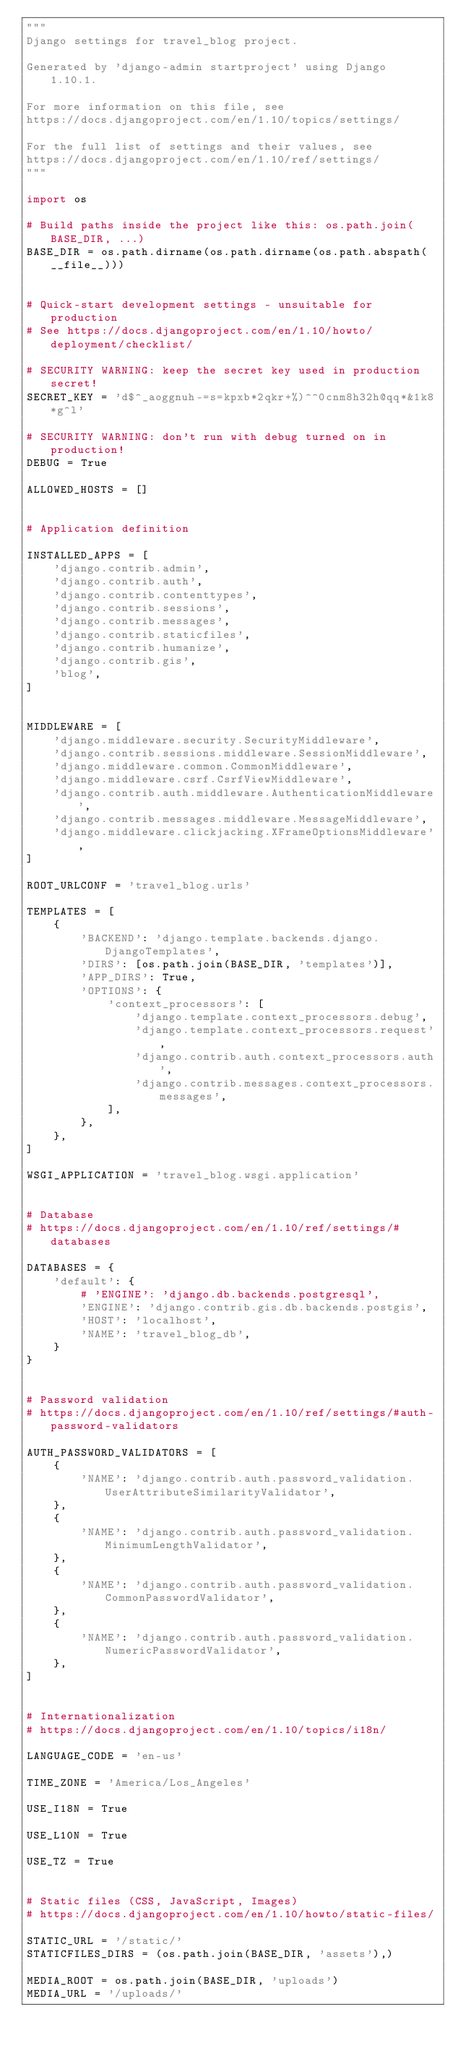Convert code to text. <code><loc_0><loc_0><loc_500><loc_500><_Python_>"""
Django settings for travel_blog project.

Generated by 'django-admin startproject' using Django 1.10.1.

For more information on this file, see
https://docs.djangoproject.com/en/1.10/topics/settings/

For the full list of settings and their values, see
https://docs.djangoproject.com/en/1.10/ref/settings/
"""

import os

# Build paths inside the project like this: os.path.join(BASE_DIR, ...)
BASE_DIR = os.path.dirname(os.path.dirname(os.path.abspath(__file__)))


# Quick-start development settings - unsuitable for production
# See https://docs.djangoproject.com/en/1.10/howto/deployment/checklist/

# SECURITY WARNING: keep the secret key used in production secret!
SECRET_KEY = 'd$^_aoggnuh-=s=kpxb*2qkr+%)^^0cnm8h32h@qq*&1k8*g^l'

# SECURITY WARNING: don't run with debug turned on in production!
DEBUG = True

ALLOWED_HOSTS = []


# Application definition

INSTALLED_APPS = [
    'django.contrib.admin',
    'django.contrib.auth',
    'django.contrib.contenttypes',
    'django.contrib.sessions',
    'django.contrib.messages',
    'django.contrib.staticfiles',
    'django.contrib.humanize',
    'django.contrib.gis',
    'blog',
]


MIDDLEWARE = [
    'django.middleware.security.SecurityMiddleware',
    'django.contrib.sessions.middleware.SessionMiddleware',
    'django.middleware.common.CommonMiddleware',
    'django.middleware.csrf.CsrfViewMiddleware',
    'django.contrib.auth.middleware.AuthenticationMiddleware',
    'django.contrib.messages.middleware.MessageMiddleware',
    'django.middleware.clickjacking.XFrameOptionsMiddleware',
]

ROOT_URLCONF = 'travel_blog.urls'

TEMPLATES = [
    {
        'BACKEND': 'django.template.backends.django.DjangoTemplates',
        'DIRS': [os.path.join(BASE_DIR, 'templates')],
        'APP_DIRS': True,
        'OPTIONS': {
            'context_processors': [
                'django.template.context_processors.debug',
                'django.template.context_processors.request',
                'django.contrib.auth.context_processors.auth',
                'django.contrib.messages.context_processors.messages',
            ],
        },
    },
]

WSGI_APPLICATION = 'travel_blog.wsgi.application'


# Database
# https://docs.djangoproject.com/en/1.10/ref/settings/#databases

DATABASES = {
    'default': {
        # 'ENGINE': 'django.db.backends.postgresql',
        'ENGINE': 'django.contrib.gis.db.backends.postgis',
        'HOST': 'localhost',
        'NAME': 'travel_blog_db',
    }
}


# Password validation
# https://docs.djangoproject.com/en/1.10/ref/settings/#auth-password-validators

AUTH_PASSWORD_VALIDATORS = [
    {
        'NAME': 'django.contrib.auth.password_validation.UserAttributeSimilarityValidator',
    },
    {
        'NAME': 'django.contrib.auth.password_validation.MinimumLengthValidator',
    },
    {
        'NAME': 'django.contrib.auth.password_validation.CommonPasswordValidator',
    },
    {
        'NAME': 'django.contrib.auth.password_validation.NumericPasswordValidator',
    },
]


# Internationalization
# https://docs.djangoproject.com/en/1.10/topics/i18n/

LANGUAGE_CODE = 'en-us'

TIME_ZONE = 'America/Los_Angeles'

USE_I18N = True

USE_L10N = True

USE_TZ = True


# Static files (CSS, JavaScript, Images)
# https://docs.djangoproject.com/en/1.10/howto/static-files/

STATIC_URL = '/static/'
STATICFILES_DIRS = (os.path.join(BASE_DIR, 'assets'),)

MEDIA_ROOT = os.path.join(BASE_DIR, 'uploads')
MEDIA_URL = '/uploads/'
</code> 